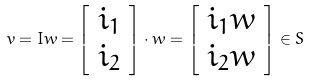Convert formula to latex. <formula><loc_0><loc_0><loc_500><loc_500>v = I w = \left [ \begin{array} { c } i _ { 1 } \\ i _ { 2 } \end{array} \right ] \cdot w = \left [ \begin{array} { c } i _ { 1 } w \\ i _ { 2 } w \end{array} \right ] \in S</formula> 